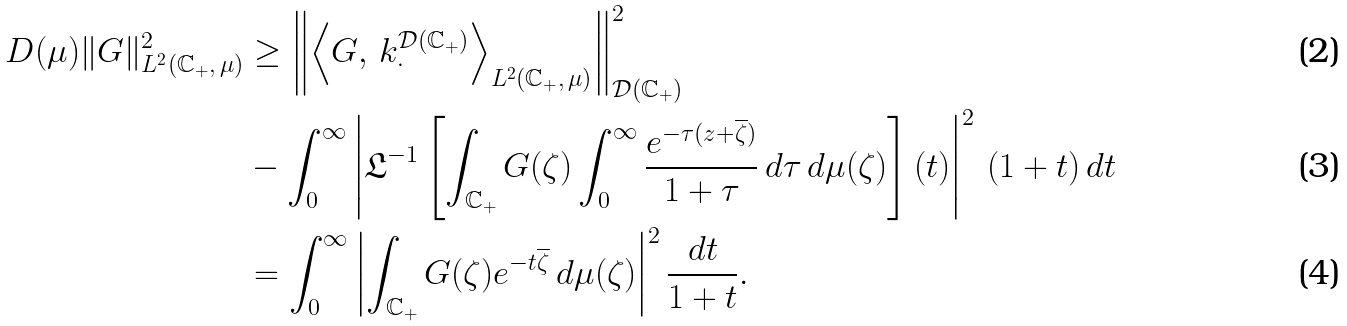Convert formula to latex. <formula><loc_0><loc_0><loc_500><loc_500>D ( \mu ) \| G \| ^ { 2 } _ { L ^ { 2 } ( \mathbb { C } _ { + } , \, \mu ) } & \geq \left \| \left \langle G , \, k ^ { \mathcal { D } ( \mathbb { C } _ { + } ) } _ { \cdot } \right \rangle _ { L ^ { 2 } ( \mathbb { C } _ { + } , \, \mu ) } \right \| ^ { 2 } _ { \mathcal { D } ( \mathbb { C } _ { + } ) } \\ & - \int _ { 0 } ^ { \infty } \left | \mathfrak { L } ^ { - 1 } \left [ \int _ { \mathbb { C } _ { + } } G ( \zeta ) \int _ { 0 } ^ { \infty } \frac { e ^ { - \tau ( z + \overline { \zeta } ) } } { 1 + \tau } \, d \tau \, d \mu ( \zeta ) \right ] ( t ) \right | ^ { 2 } \, ( 1 + t ) \, d t \\ & = \int _ { 0 } ^ { \infty } \left | \int _ { \mathbb { C } _ { + } } G ( \zeta ) e ^ { - t \overline { \zeta } } \, d \mu ( \zeta ) \right | ^ { 2 } \frac { d t } { 1 + t } .</formula> 